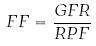Convert formula to latex. <formula><loc_0><loc_0><loc_500><loc_500>F F = \frac { G F R } { R P F }</formula> 